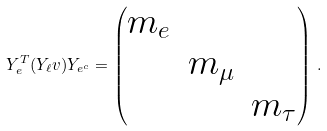Convert formula to latex. <formula><loc_0><loc_0><loc_500><loc_500>Y _ { e } ^ { T } ( Y _ { \ell } v ) Y _ { e ^ { c } } = \left ( \begin{matrix} m _ { e } & & \\ & m _ { \mu } & \\ & & m _ { \tau } \end{matrix} \right ) \, .</formula> 